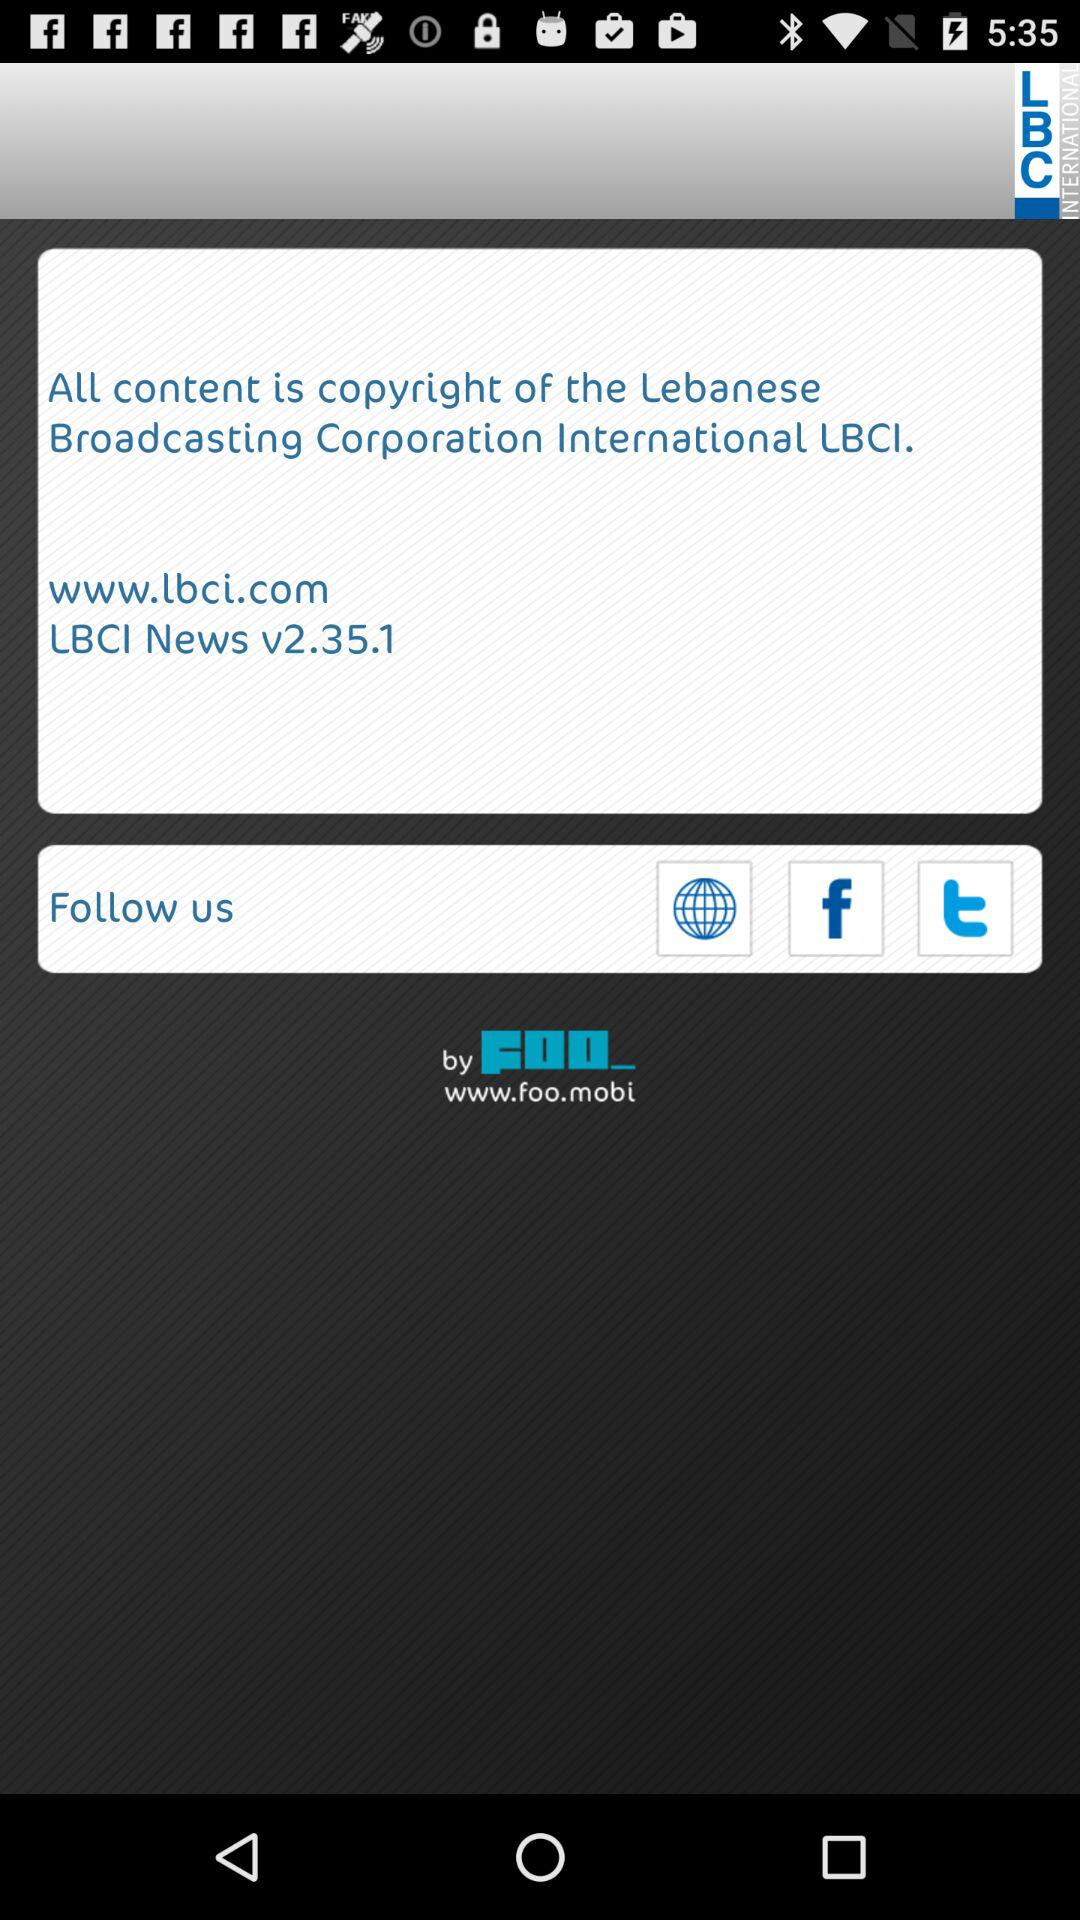What is the website? The website is www.lbci.com. 